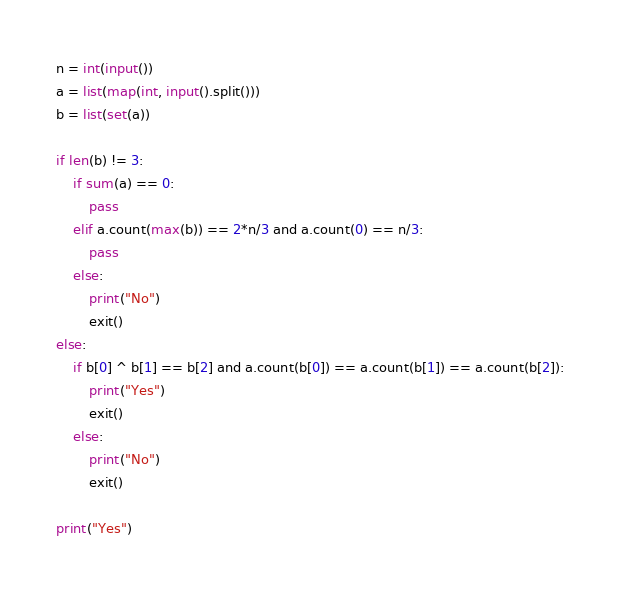<code> <loc_0><loc_0><loc_500><loc_500><_Python_>n = int(input())
a = list(map(int, input().split()))
b = list(set(a))

if len(b) != 3:
    if sum(a) == 0:
        pass
    elif a.count(max(b)) == 2*n/3 and a.count(0) == n/3:
        pass
    else:
        print("No")
        exit()
else:
    if b[0] ^ b[1] == b[2] and a.count(b[0]) == a.count(b[1]) == a.count(b[2]):
        print("Yes")
        exit()
    else:
        print("No")
        exit()
        
print("Yes")</code> 